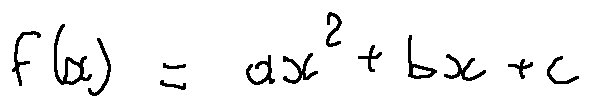<formula> <loc_0><loc_0><loc_500><loc_500>f ( x ) = a x ^ { 2 } + b x + c</formula> 